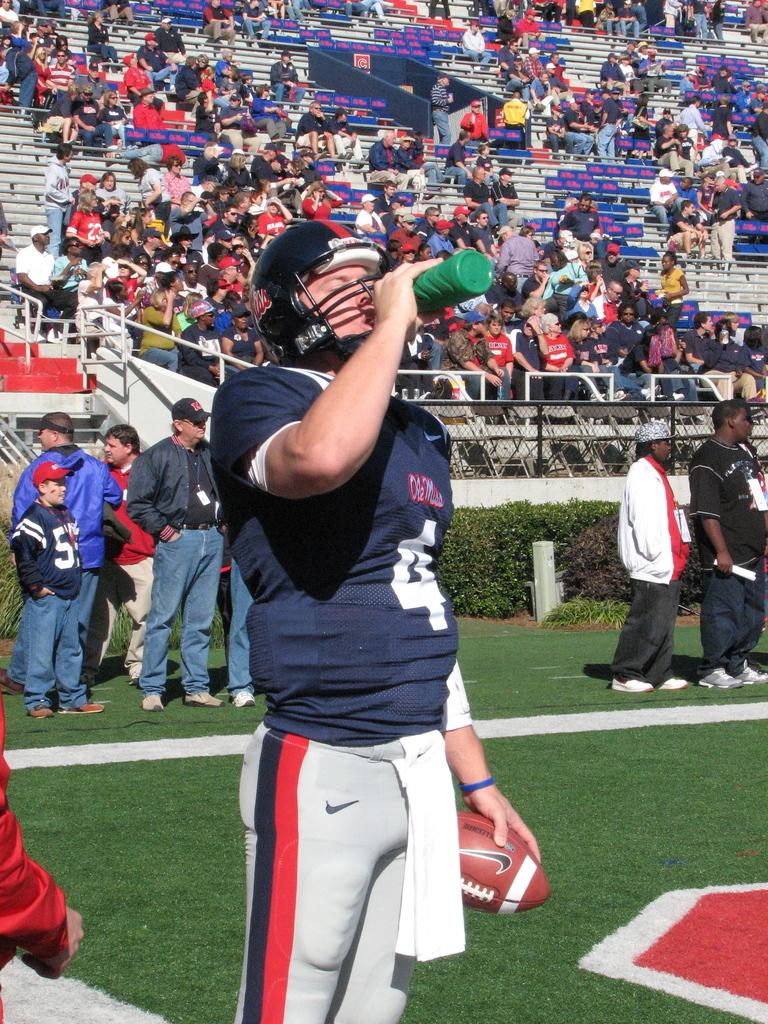How many people are in the image? There are people in the image, but the exact number is not specified. What are some people doing in the image? Some people are on the ground, and one person on the ground is holding a ball. What is the person holding the ball wearing? The person holding the ball is wearing a helmet. What is the person holding the ball doing? The person holding the ball is drinking water. What can be seen in the background of the image? There are people in the stands and a fence in the image. What type of cap is the country wearing in the image? There is no country or cap present in the image. What is the pump used for in the image? There is no pump present in the image. 